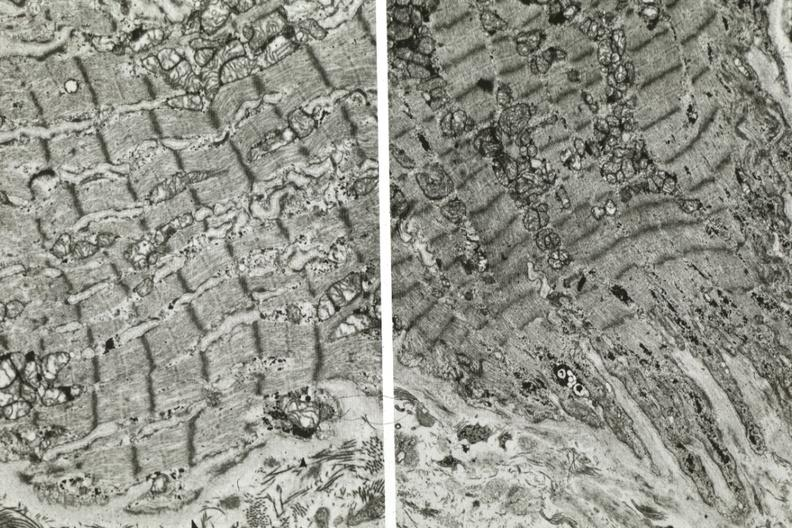what is present?
Answer the question using a single word or phrase. Cardiovascular 